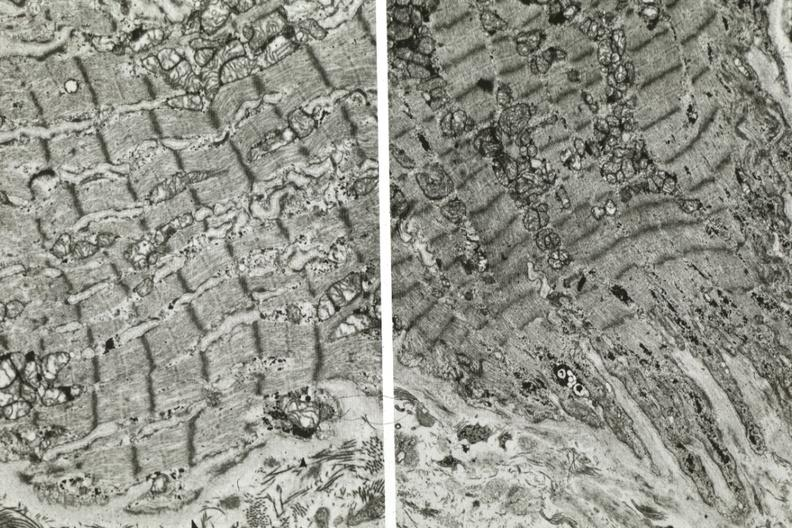what is present?
Answer the question using a single word or phrase. Cardiovascular 